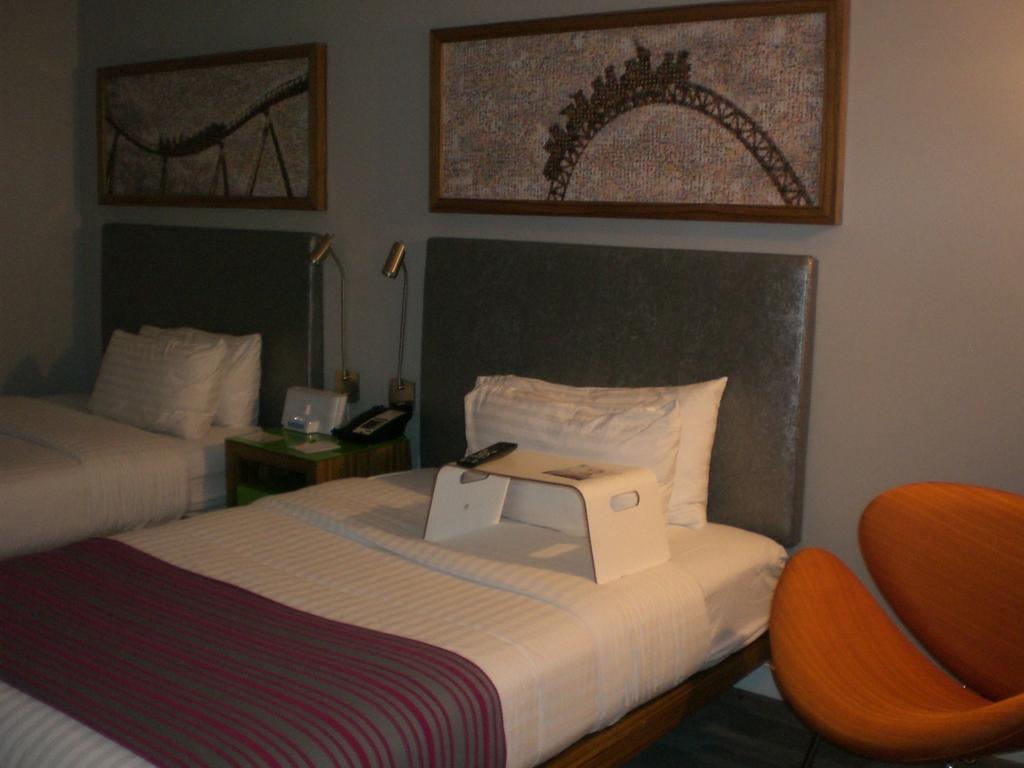Please provide a concise description of this image. The image is taken in a room. In the image there are two beds, pillows, desk, couch, remote, lamps and various objects. At the top there are frames to the wall. 